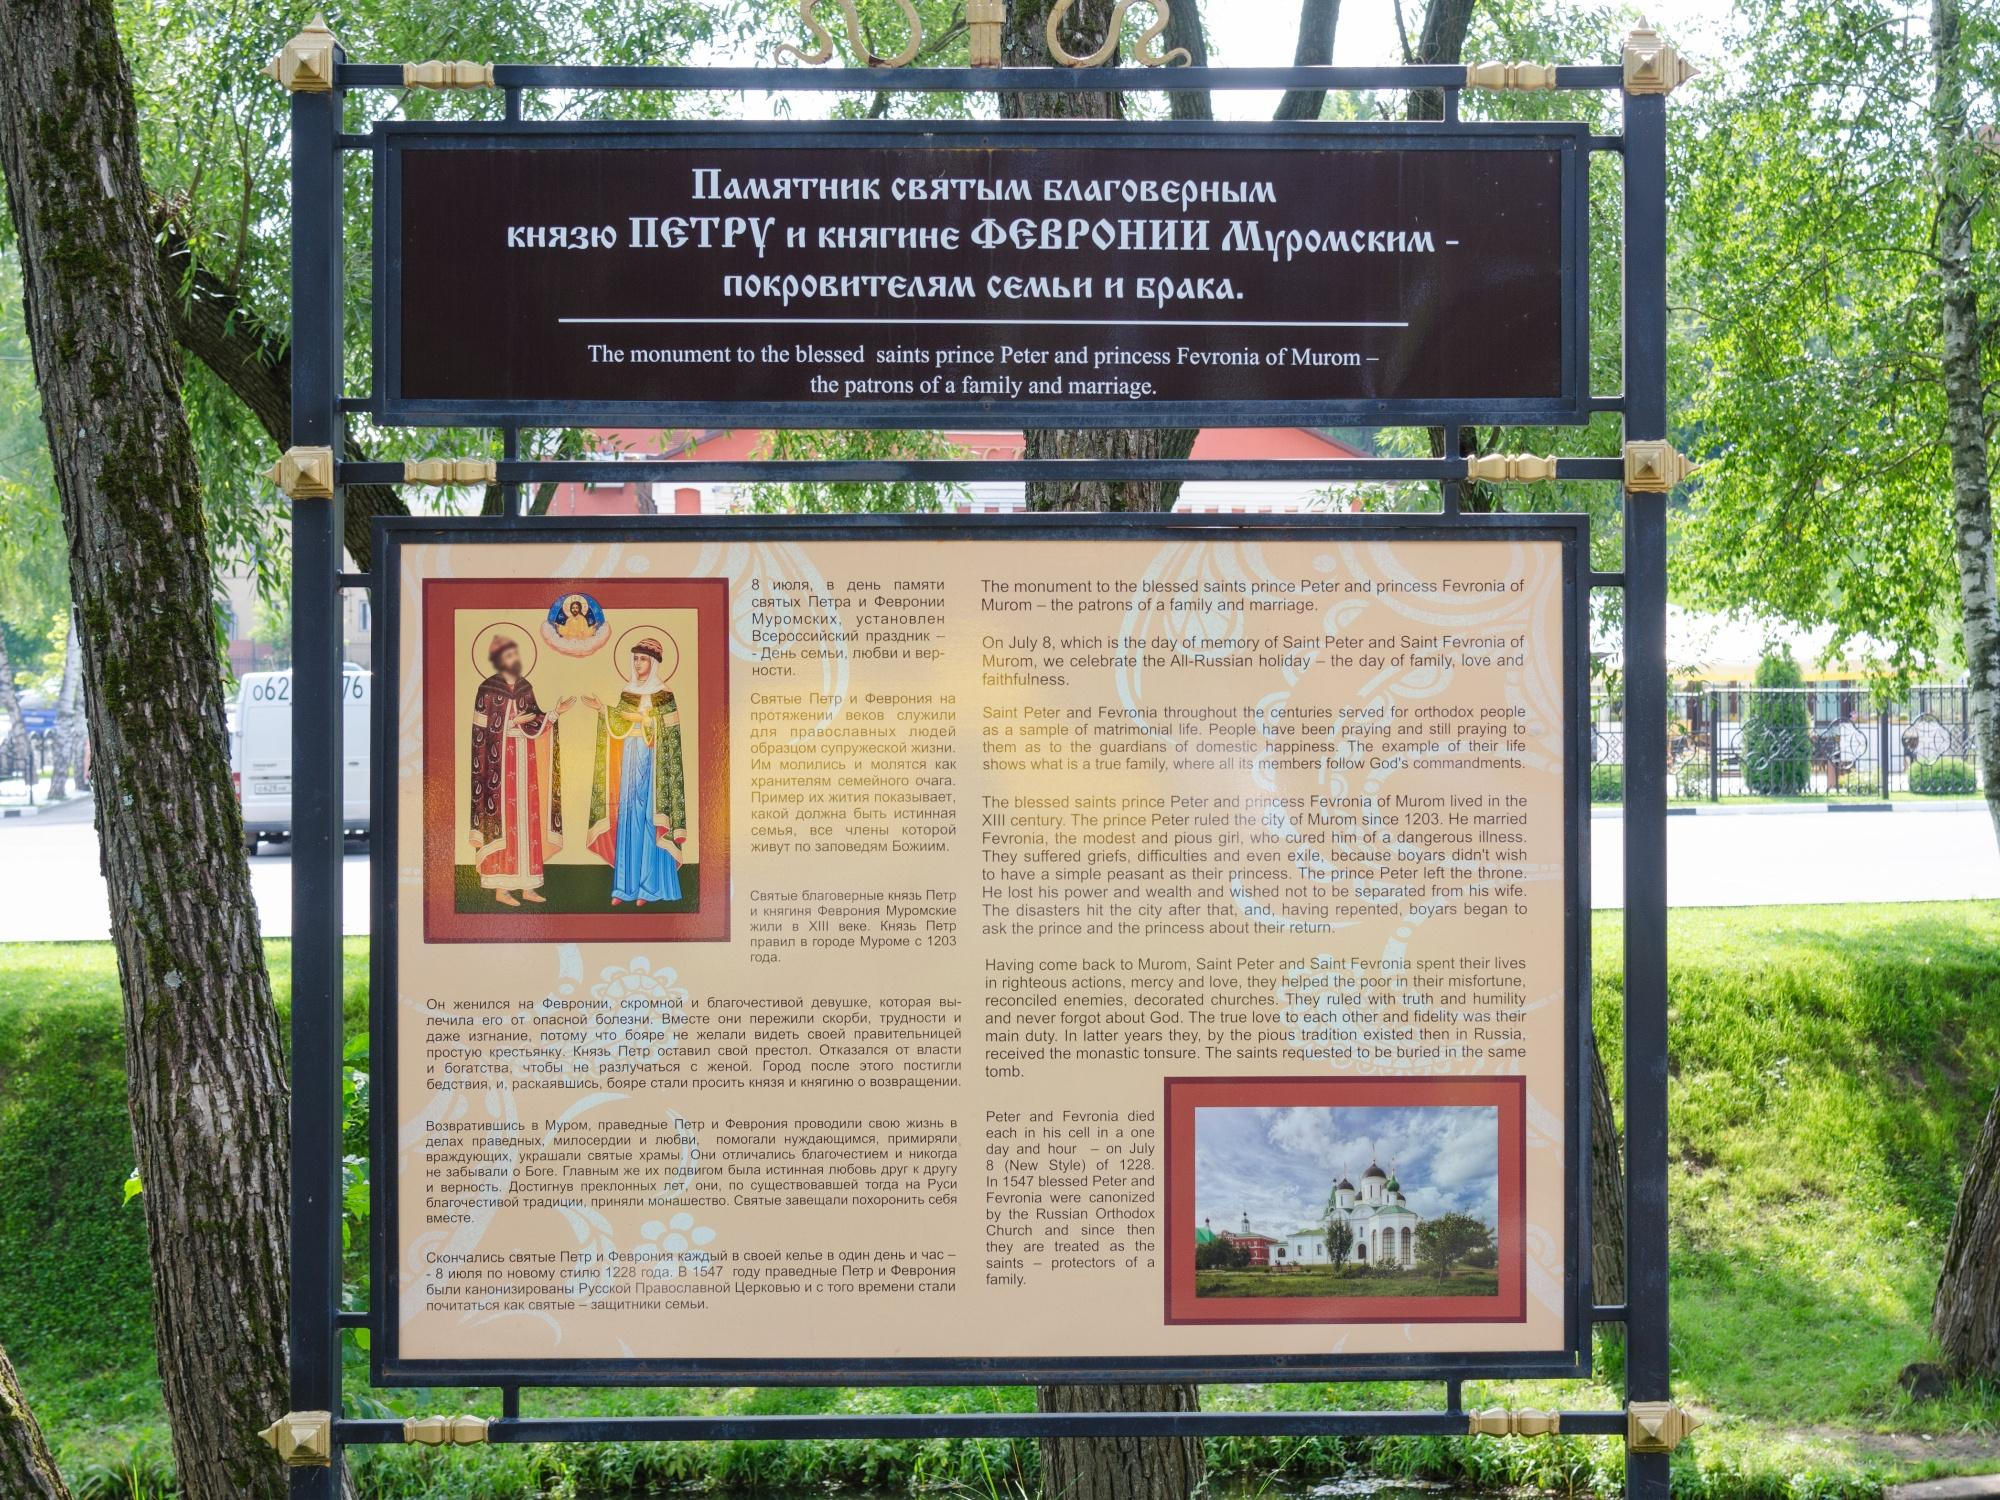Can you tell more about Prince Peter and Princess Fevronia and why they are important? Prince Peter and Princess Fevronia of Murom are revered in Russian history as symbols of faith and fidelity in marriage. Celebrated on July 8th, their feast day, known as the Day of Family, Love, and Fidelity, highlights their story of commitment and love, which transcended even death, as they insisted on being buried together. Their tale promotes the values of loyalty, love, and the sanctity of marriage, standing as moral exemplars in Russian orthodoxy. 